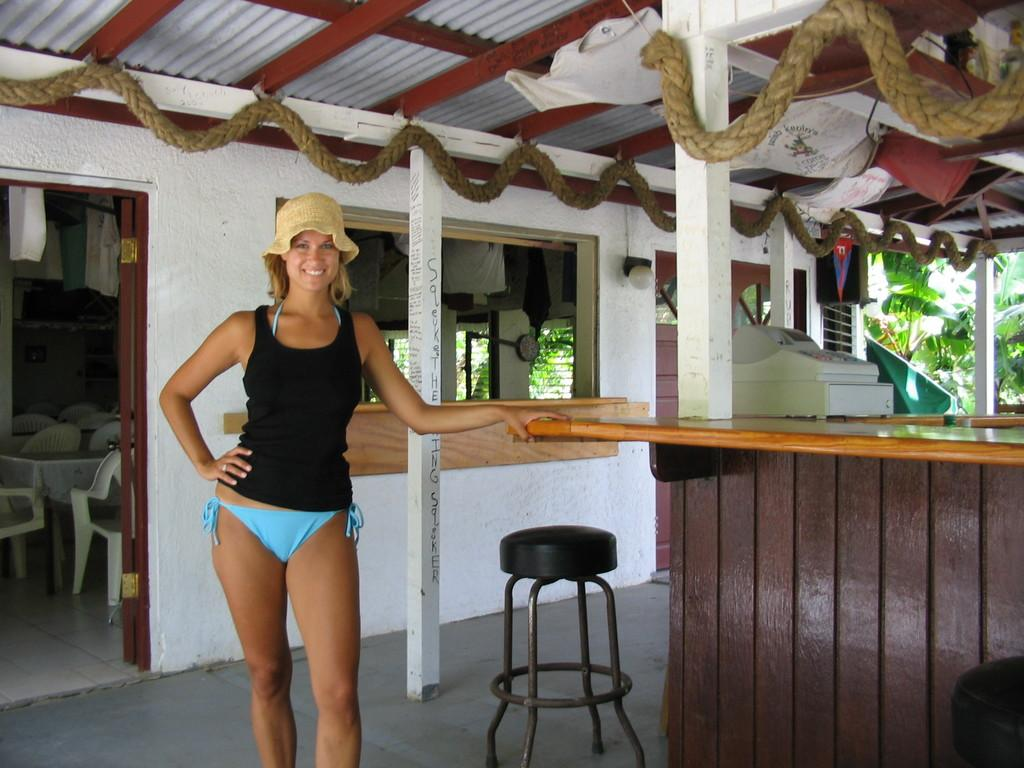What is the main subject in the image? There is a woman standing in the image. What object can be seen near the woman? There is a stool in the image. What device is present on a desk in the image? There is a billing machine on a desk in the image. What can be seen in the background of the image? There is another room visible in the image, which contains empty chairs and tables. What type of power is the woman experiencing in the image? There is no indication of any power being experienced by the woman in the image. 